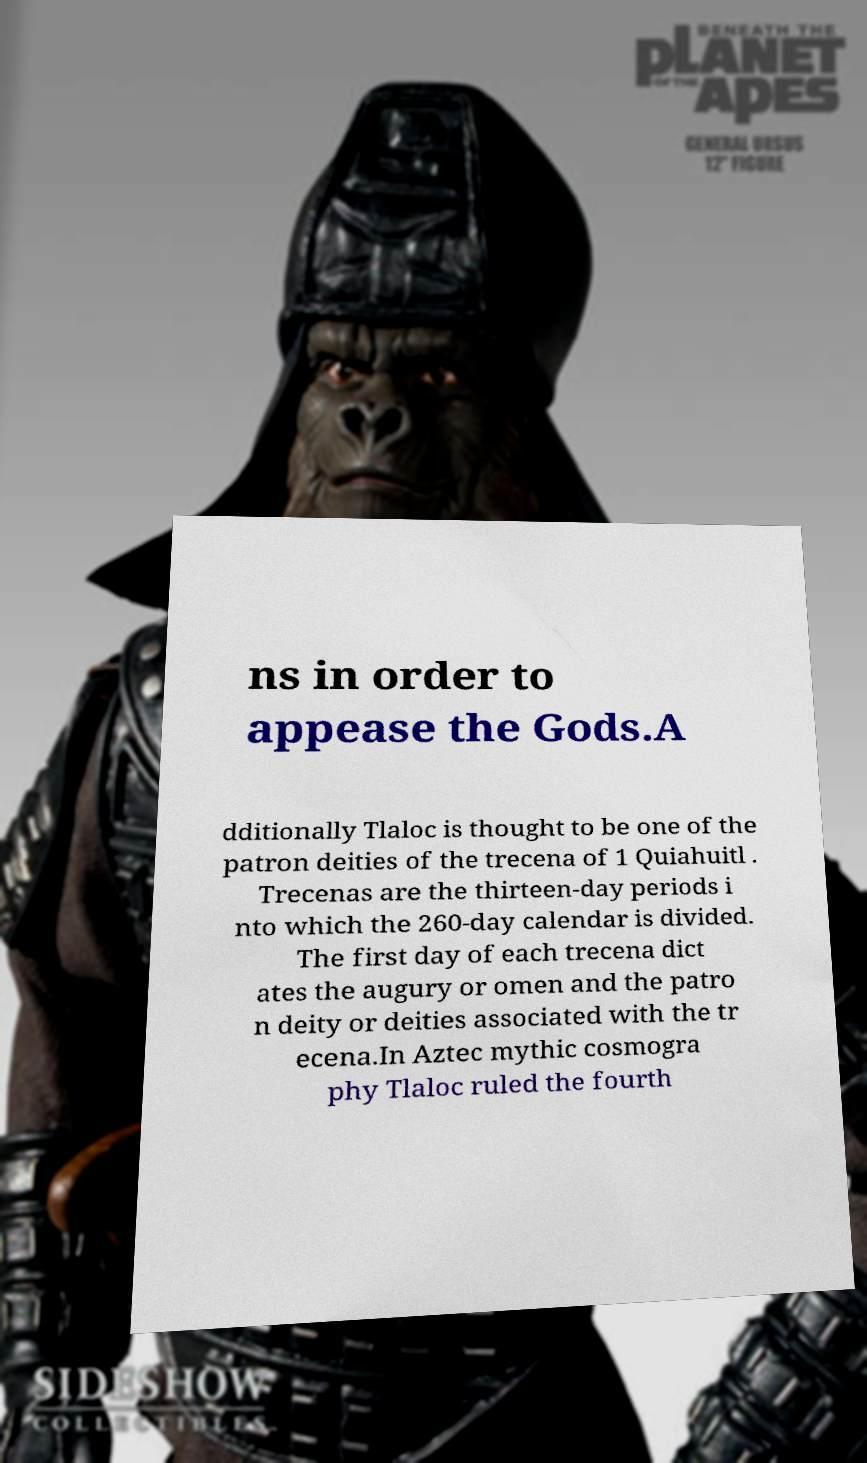What messages or text are displayed in this image? I need them in a readable, typed format. ns in order to appease the Gods.A dditionally Tlaloc is thought to be one of the patron deities of the trecena of 1 Quiahuitl . Trecenas are the thirteen-day periods i nto which the 260-day calendar is divided. The first day of each trecena dict ates the augury or omen and the patro n deity or deities associated with the tr ecena.In Aztec mythic cosmogra phy Tlaloc ruled the fourth 